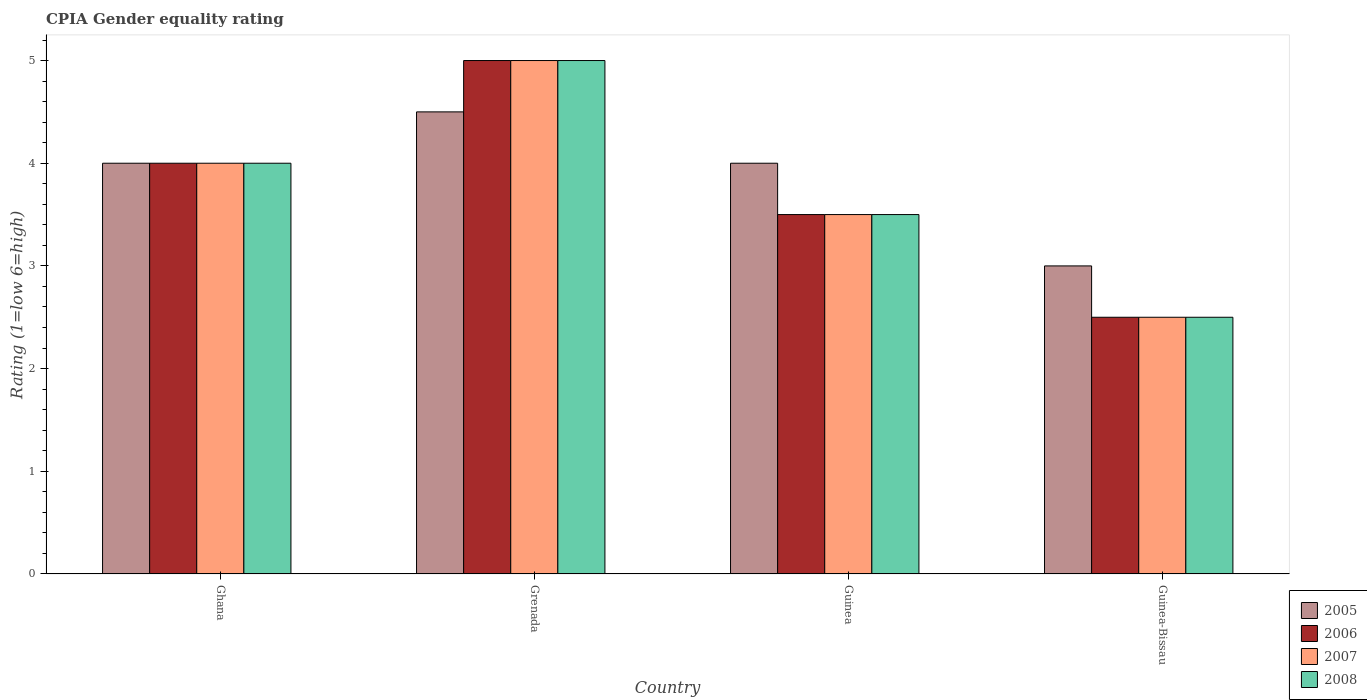How many different coloured bars are there?
Ensure brevity in your answer.  4. Are the number of bars per tick equal to the number of legend labels?
Ensure brevity in your answer.  Yes. Are the number of bars on each tick of the X-axis equal?
Give a very brief answer. Yes. How many bars are there on the 2nd tick from the left?
Your response must be concise. 4. How many bars are there on the 4th tick from the right?
Provide a short and direct response. 4. What is the label of the 4th group of bars from the left?
Provide a short and direct response. Guinea-Bissau. What is the CPIA rating in 2006 in Grenada?
Offer a terse response. 5. In which country was the CPIA rating in 2005 maximum?
Make the answer very short. Grenada. In which country was the CPIA rating in 2005 minimum?
Offer a terse response. Guinea-Bissau. What is the total CPIA rating in 2005 in the graph?
Offer a terse response. 15.5. What is the difference between the CPIA rating in 2007 in Ghana and that in Guinea?
Ensure brevity in your answer.  0.5. What is the difference between the CPIA rating in 2007 in Guinea and the CPIA rating in 2006 in Grenada?
Give a very brief answer. -1.5. What is the average CPIA rating in 2008 per country?
Provide a succinct answer. 3.75. What is the difference between the CPIA rating of/in 2008 and CPIA rating of/in 2006 in Grenada?
Provide a short and direct response. 0. In how many countries, is the CPIA rating in 2005 greater than 0.6000000000000001?
Provide a short and direct response. 4. What is the ratio of the CPIA rating in 2006 in Grenada to that in Guinea?
Provide a succinct answer. 1.43. Is the CPIA rating in 2008 in Ghana less than that in Grenada?
Your answer should be compact. Yes. Is the difference between the CPIA rating in 2008 in Ghana and Guinea-Bissau greater than the difference between the CPIA rating in 2006 in Ghana and Guinea-Bissau?
Your answer should be compact. No. What is the difference between the highest and the second highest CPIA rating in 2007?
Keep it short and to the point. -0.5. Is the sum of the CPIA rating in 2008 in Ghana and Guinea greater than the maximum CPIA rating in 2006 across all countries?
Offer a terse response. Yes. Is it the case that in every country, the sum of the CPIA rating in 2007 and CPIA rating in 2005 is greater than the sum of CPIA rating in 2008 and CPIA rating in 2006?
Provide a short and direct response. No. What does the 3rd bar from the left in Guinea represents?
Give a very brief answer. 2007. What does the 4th bar from the right in Guinea represents?
Your answer should be compact. 2005. Is it the case that in every country, the sum of the CPIA rating in 2008 and CPIA rating in 2007 is greater than the CPIA rating in 2005?
Make the answer very short. Yes. How many bars are there?
Provide a short and direct response. 16. What is the difference between two consecutive major ticks on the Y-axis?
Keep it short and to the point. 1. Are the values on the major ticks of Y-axis written in scientific E-notation?
Your answer should be compact. No. Does the graph contain any zero values?
Offer a very short reply. No. Does the graph contain grids?
Ensure brevity in your answer.  No. How many legend labels are there?
Make the answer very short. 4. What is the title of the graph?
Provide a short and direct response. CPIA Gender equality rating. Does "1993" appear as one of the legend labels in the graph?
Your answer should be compact. No. What is the label or title of the X-axis?
Offer a terse response. Country. What is the Rating (1=low 6=high) in 2005 in Ghana?
Offer a terse response. 4. What is the Rating (1=low 6=high) in 2007 in Guinea?
Provide a succinct answer. 3.5. What is the Rating (1=low 6=high) of 2008 in Guinea?
Offer a terse response. 3.5. What is the Rating (1=low 6=high) of 2006 in Guinea-Bissau?
Provide a short and direct response. 2.5. What is the Rating (1=low 6=high) of 2007 in Guinea-Bissau?
Ensure brevity in your answer.  2.5. Across all countries, what is the maximum Rating (1=low 6=high) of 2005?
Keep it short and to the point. 4.5. Across all countries, what is the maximum Rating (1=low 6=high) of 2006?
Ensure brevity in your answer.  5. Across all countries, what is the maximum Rating (1=low 6=high) in 2007?
Offer a terse response. 5. Across all countries, what is the maximum Rating (1=low 6=high) in 2008?
Give a very brief answer. 5. Across all countries, what is the minimum Rating (1=low 6=high) of 2005?
Ensure brevity in your answer.  3. Across all countries, what is the minimum Rating (1=low 6=high) of 2006?
Provide a succinct answer. 2.5. What is the total Rating (1=low 6=high) in 2006 in the graph?
Keep it short and to the point. 15. What is the total Rating (1=low 6=high) of 2007 in the graph?
Ensure brevity in your answer.  15. What is the difference between the Rating (1=low 6=high) of 2005 in Ghana and that in Guinea?
Provide a succinct answer. 0. What is the difference between the Rating (1=low 6=high) in 2006 in Ghana and that in Guinea?
Keep it short and to the point. 0.5. What is the difference between the Rating (1=low 6=high) of 2007 in Ghana and that in Guinea?
Offer a terse response. 0.5. What is the difference between the Rating (1=low 6=high) in 2006 in Ghana and that in Guinea-Bissau?
Your answer should be very brief. 1.5. What is the difference between the Rating (1=low 6=high) of 2005 in Grenada and that in Guinea?
Make the answer very short. 0.5. What is the difference between the Rating (1=low 6=high) of 2007 in Grenada and that in Guinea?
Offer a very short reply. 1.5. What is the difference between the Rating (1=low 6=high) of 2008 in Grenada and that in Guinea?
Provide a short and direct response. 1.5. What is the difference between the Rating (1=low 6=high) in 2005 in Grenada and that in Guinea-Bissau?
Make the answer very short. 1.5. What is the difference between the Rating (1=low 6=high) in 2005 in Guinea and that in Guinea-Bissau?
Offer a terse response. 1. What is the difference between the Rating (1=low 6=high) in 2008 in Guinea and that in Guinea-Bissau?
Give a very brief answer. 1. What is the difference between the Rating (1=low 6=high) of 2005 in Ghana and the Rating (1=low 6=high) of 2007 in Grenada?
Your answer should be compact. -1. What is the difference between the Rating (1=low 6=high) in 2005 in Ghana and the Rating (1=low 6=high) in 2008 in Grenada?
Give a very brief answer. -1. What is the difference between the Rating (1=low 6=high) in 2006 in Ghana and the Rating (1=low 6=high) in 2007 in Guinea?
Ensure brevity in your answer.  0.5. What is the difference between the Rating (1=low 6=high) in 2005 in Ghana and the Rating (1=low 6=high) in 2006 in Guinea-Bissau?
Give a very brief answer. 1.5. What is the difference between the Rating (1=low 6=high) of 2005 in Ghana and the Rating (1=low 6=high) of 2007 in Guinea-Bissau?
Provide a succinct answer. 1.5. What is the difference between the Rating (1=low 6=high) of 2006 in Ghana and the Rating (1=low 6=high) of 2007 in Guinea-Bissau?
Provide a succinct answer. 1.5. What is the difference between the Rating (1=low 6=high) of 2006 in Ghana and the Rating (1=low 6=high) of 2008 in Guinea-Bissau?
Ensure brevity in your answer.  1.5. What is the difference between the Rating (1=low 6=high) of 2005 in Grenada and the Rating (1=low 6=high) of 2006 in Guinea?
Your answer should be compact. 1. What is the difference between the Rating (1=low 6=high) of 2006 in Grenada and the Rating (1=low 6=high) of 2007 in Guinea?
Give a very brief answer. 1.5. What is the difference between the Rating (1=low 6=high) in 2006 in Grenada and the Rating (1=low 6=high) in 2008 in Guinea?
Make the answer very short. 1.5. What is the difference between the Rating (1=low 6=high) in 2007 in Grenada and the Rating (1=low 6=high) in 2008 in Guinea?
Provide a short and direct response. 1.5. What is the difference between the Rating (1=low 6=high) of 2005 in Grenada and the Rating (1=low 6=high) of 2006 in Guinea-Bissau?
Offer a terse response. 2. What is the difference between the Rating (1=low 6=high) of 2005 in Grenada and the Rating (1=low 6=high) of 2008 in Guinea-Bissau?
Ensure brevity in your answer.  2. What is the difference between the Rating (1=low 6=high) of 2006 in Grenada and the Rating (1=low 6=high) of 2007 in Guinea-Bissau?
Give a very brief answer. 2.5. What is the difference between the Rating (1=low 6=high) in 2007 in Grenada and the Rating (1=low 6=high) in 2008 in Guinea-Bissau?
Offer a terse response. 2.5. What is the difference between the Rating (1=low 6=high) in 2005 in Guinea and the Rating (1=low 6=high) in 2006 in Guinea-Bissau?
Offer a terse response. 1.5. What is the difference between the Rating (1=low 6=high) in 2005 in Guinea and the Rating (1=low 6=high) in 2007 in Guinea-Bissau?
Make the answer very short. 1.5. What is the difference between the Rating (1=low 6=high) in 2006 in Guinea and the Rating (1=low 6=high) in 2008 in Guinea-Bissau?
Ensure brevity in your answer.  1. What is the average Rating (1=low 6=high) in 2005 per country?
Make the answer very short. 3.88. What is the average Rating (1=low 6=high) of 2006 per country?
Provide a succinct answer. 3.75. What is the average Rating (1=low 6=high) in 2007 per country?
Offer a terse response. 3.75. What is the average Rating (1=low 6=high) in 2008 per country?
Make the answer very short. 3.75. What is the difference between the Rating (1=low 6=high) in 2005 and Rating (1=low 6=high) in 2006 in Ghana?
Your answer should be very brief. 0. What is the difference between the Rating (1=low 6=high) in 2005 and Rating (1=low 6=high) in 2008 in Ghana?
Give a very brief answer. 0. What is the difference between the Rating (1=low 6=high) of 2006 and Rating (1=low 6=high) of 2008 in Ghana?
Your answer should be compact. 0. What is the difference between the Rating (1=low 6=high) in 2007 and Rating (1=low 6=high) in 2008 in Ghana?
Give a very brief answer. 0. What is the difference between the Rating (1=low 6=high) of 2005 and Rating (1=low 6=high) of 2006 in Grenada?
Make the answer very short. -0.5. What is the difference between the Rating (1=low 6=high) in 2005 and Rating (1=low 6=high) in 2007 in Grenada?
Ensure brevity in your answer.  -0.5. What is the difference between the Rating (1=low 6=high) of 2005 and Rating (1=low 6=high) of 2008 in Grenada?
Your response must be concise. -0.5. What is the difference between the Rating (1=low 6=high) of 2006 and Rating (1=low 6=high) of 2007 in Grenada?
Your response must be concise. 0. What is the difference between the Rating (1=low 6=high) in 2005 and Rating (1=low 6=high) in 2007 in Guinea?
Your answer should be very brief. 0.5. What is the difference between the Rating (1=low 6=high) of 2005 and Rating (1=low 6=high) of 2006 in Guinea-Bissau?
Keep it short and to the point. 0.5. What is the difference between the Rating (1=low 6=high) in 2005 and Rating (1=low 6=high) in 2008 in Guinea-Bissau?
Your answer should be compact. 0.5. What is the difference between the Rating (1=low 6=high) in 2006 and Rating (1=low 6=high) in 2007 in Guinea-Bissau?
Your response must be concise. 0. What is the ratio of the Rating (1=low 6=high) of 2006 in Ghana to that in Grenada?
Your answer should be compact. 0.8. What is the ratio of the Rating (1=low 6=high) in 2007 in Ghana to that in Grenada?
Offer a very short reply. 0.8. What is the ratio of the Rating (1=low 6=high) of 2008 in Ghana to that in Grenada?
Your answer should be compact. 0.8. What is the ratio of the Rating (1=low 6=high) in 2006 in Ghana to that in Guinea?
Your answer should be very brief. 1.14. What is the ratio of the Rating (1=low 6=high) in 2007 in Ghana to that in Guinea?
Give a very brief answer. 1.14. What is the ratio of the Rating (1=low 6=high) in 2005 in Ghana to that in Guinea-Bissau?
Keep it short and to the point. 1.33. What is the ratio of the Rating (1=low 6=high) in 2006 in Ghana to that in Guinea-Bissau?
Your answer should be compact. 1.6. What is the ratio of the Rating (1=low 6=high) in 2005 in Grenada to that in Guinea?
Offer a terse response. 1.12. What is the ratio of the Rating (1=low 6=high) in 2006 in Grenada to that in Guinea?
Ensure brevity in your answer.  1.43. What is the ratio of the Rating (1=low 6=high) in 2007 in Grenada to that in Guinea?
Offer a very short reply. 1.43. What is the ratio of the Rating (1=low 6=high) in 2008 in Grenada to that in Guinea?
Ensure brevity in your answer.  1.43. What is the ratio of the Rating (1=low 6=high) of 2007 in Grenada to that in Guinea-Bissau?
Provide a succinct answer. 2. What is the ratio of the Rating (1=low 6=high) in 2005 in Guinea to that in Guinea-Bissau?
Provide a succinct answer. 1.33. What is the ratio of the Rating (1=low 6=high) of 2008 in Guinea to that in Guinea-Bissau?
Your response must be concise. 1.4. What is the difference between the highest and the second highest Rating (1=low 6=high) in 2008?
Give a very brief answer. 1. What is the difference between the highest and the lowest Rating (1=low 6=high) in 2007?
Provide a succinct answer. 2.5. 